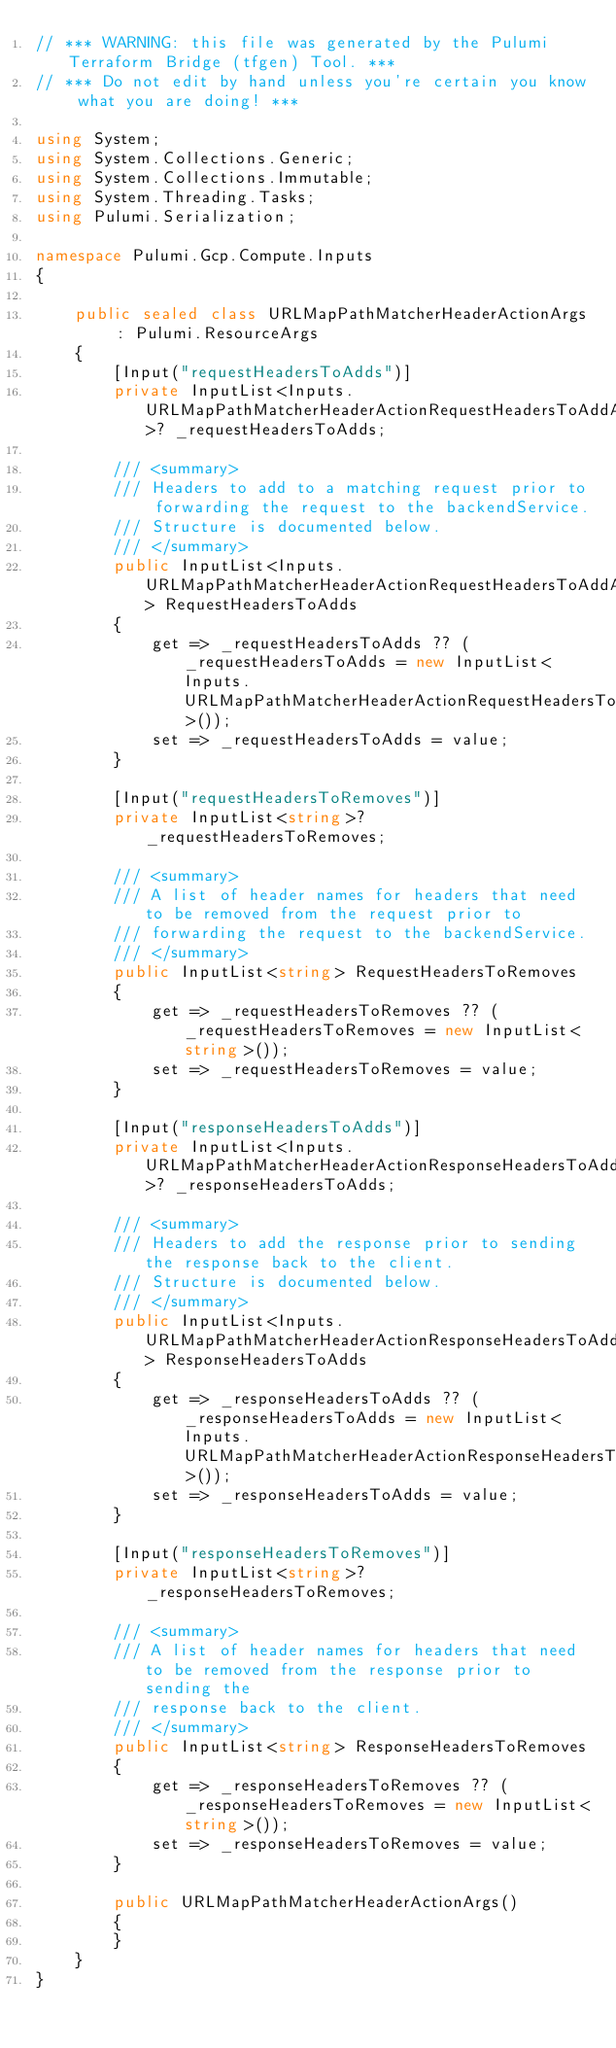Convert code to text. <code><loc_0><loc_0><loc_500><loc_500><_C#_>// *** WARNING: this file was generated by the Pulumi Terraform Bridge (tfgen) Tool. ***
// *** Do not edit by hand unless you're certain you know what you are doing! ***

using System;
using System.Collections.Generic;
using System.Collections.Immutable;
using System.Threading.Tasks;
using Pulumi.Serialization;

namespace Pulumi.Gcp.Compute.Inputs
{

    public sealed class URLMapPathMatcherHeaderActionArgs : Pulumi.ResourceArgs
    {
        [Input("requestHeadersToAdds")]
        private InputList<Inputs.URLMapPathMatcherHeaderActionRequestHeadersToAddArgs>? _requestHeadersToAdds;

        /// <summary>
        /// Headers to add to a matching request prior to forwarding the request to the backendService.
        /// Structure is documented below.
        /// </summary>
        public InputList<Inputs.URLMapPathMatcherHeaderActionRequestHeadersToAddArgs> RequestHeadersToAdds
        {
            get => _requestHeadersToAdds ?? (_requestHeadersToAdds = new InputList<Inputs.URLMapPathMatcherHeaderActionRequestHeadersToAddArgs>());
            set => _requestHeadersToAdds = value;
        }

        [Input("requestHeadersToRemoves")]
        private InputList<string>? _requestHeadersToRemoves;

        /// <summary>
        /// A list of header names for headers that need to be removed from the request prior to
        /// forwarding the request to the backendService.
        /// </summary>
        public InputList<string> RequestHeadersToRemoves
        {
            get => _requestHeadersToRemoves ?? (_requestHeadersToRemoves = new InputList<string>());
            set => _requestHeadersToRemoves = value;
        }

        [Input("responseHeadersToAdds")]
        private InputList<Inputs.URLMapPathMatcherHeaderActionResponseHeadersToAddArgs>? _responseHeadersToAdds;

        /// <summary>
        /// Headers to add the response prior to sending the response back to the client.
        /// Structure is documented below.
        /// </summary>
        public InputList<Inputs.URLMapPathMatcherHeaderActionResponseHeadersToAddArgs> ResponseHeadersToAdds
        {
            get => _responseHeadersToAdds ?? (_responseHeadersToAdds = new InputList<Inputs.URLMapPathMatcherHeaderActionResponseHeadersToAddArgs>());
            set => _responseHeadersToAdds = value;
        }

        [Input("responseHeadersToRemoves")]
        private InputList<string>? _responseHeadersToRemoves;

        /// <summary>
        /// A list of header names for headers that need to be removed from the response prior to sending the
        /// response back to the client.
        /// </summary>
        public InputList<string> ResponseHeadersToRemoves
        {
            get => _responseHeadersToRemoves ?? (_responseHeadersToRemoves = new InputList<string>());
            set => _responseHeadersToRemoves = value;
        }

        public URLMapPathMatcherHeaderActionArgs()
        {
        }
    }
}
</code> 